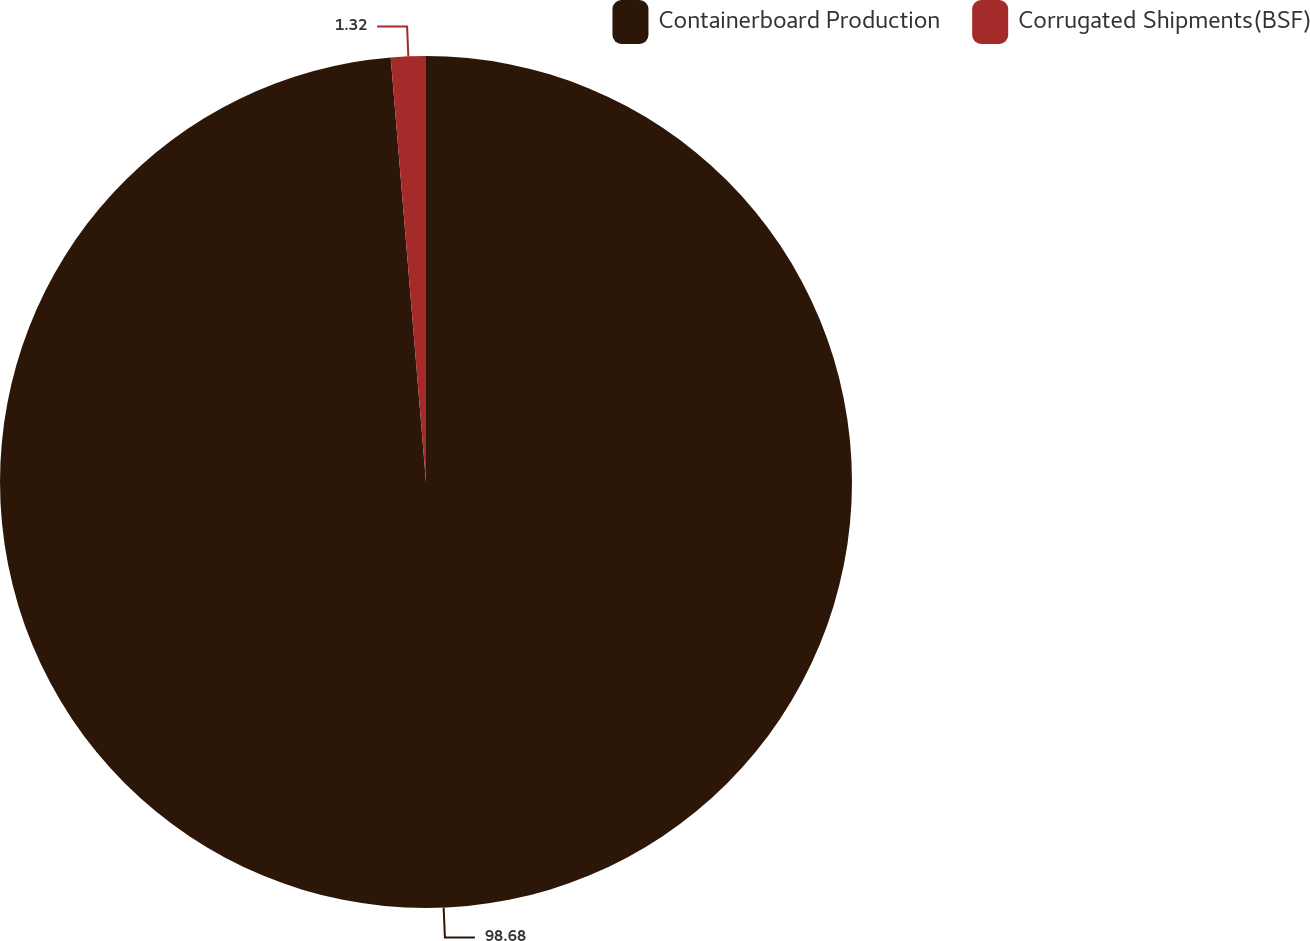Convert chart to OTSL. <chart><loc_0><loc_0><loc_500><loc_500><pie_chart><fcel>Containerboard Production<fcel>Corrugated Shipments(BSF)<nl><fcel>98.68%<fcel>1.32%<nl></chart> 